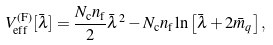<formula> <loc_0><loc_0><loc_500><loc_500>V _ { \text {eff} } ^ { \text {(F)} } [ \bar { \lambda } ] = \frac { N _ { \text {c} } n _ { \text {f} } } { 2 } \bar { \lambda } ^ { 2 } - N _ { \text {c} } n _ { \text {f} } \ln \left [ \bar { \lambda } + 2 \bar { m } _ { q } \right ] ,</formula> 